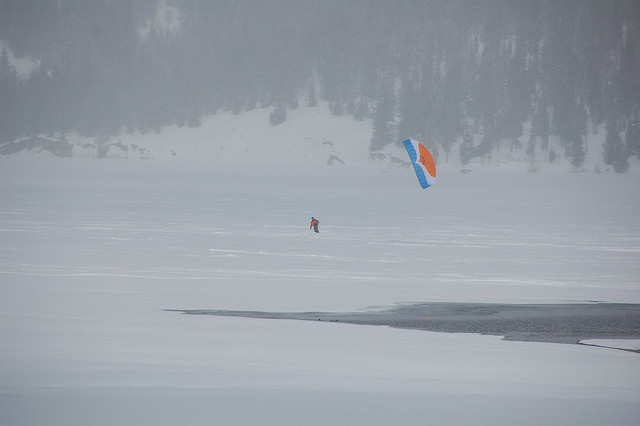Describe the objects in this image and their specific colors. I can see kite in gray, salmon, and darkgray tones and people in gray, brown, and darkgray tones in this image. 